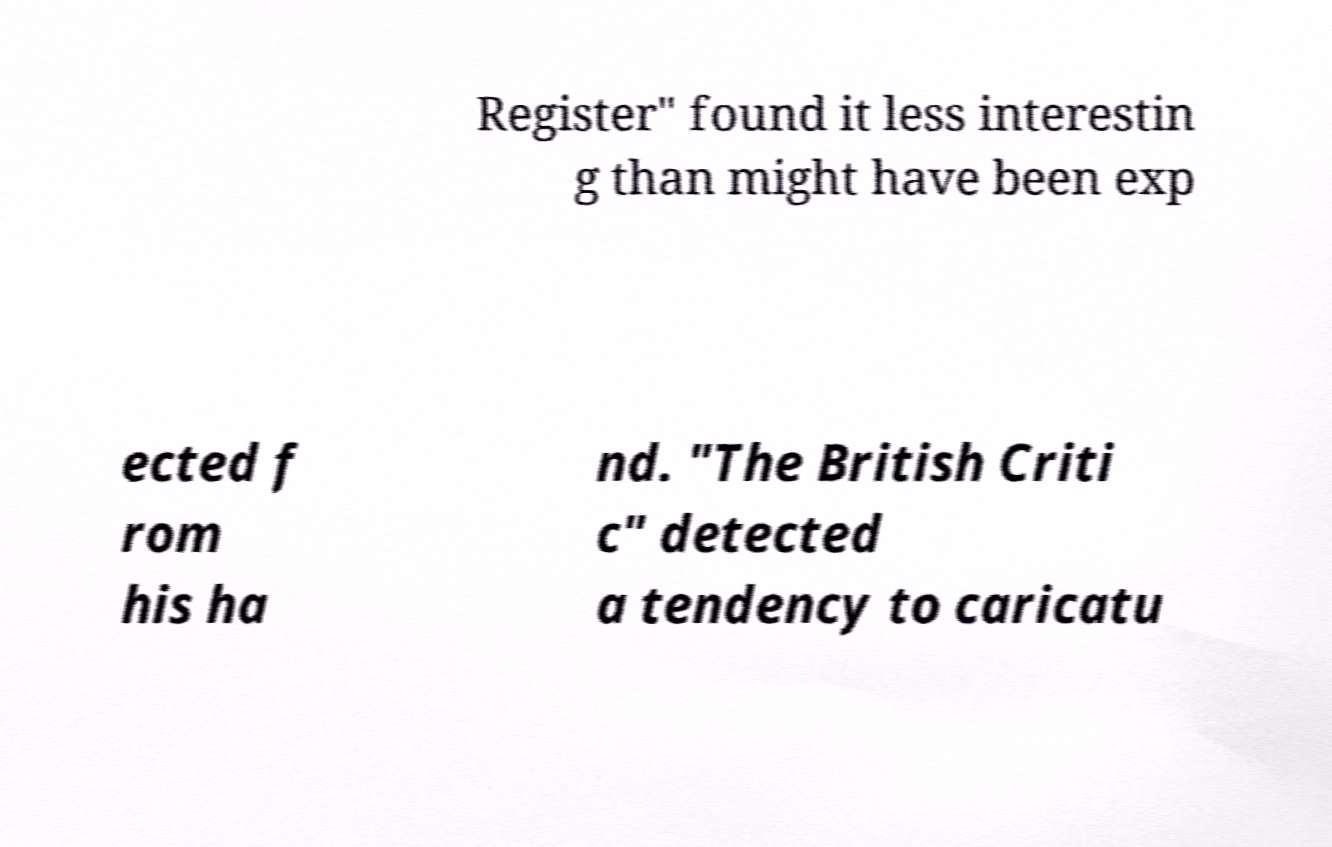Can you accurately transcribe the text from the provided image for me? Register" found it less interestin g than might have been exp ected f rom his ha nd. "The British Criti c" detected a tendency to caricatu 